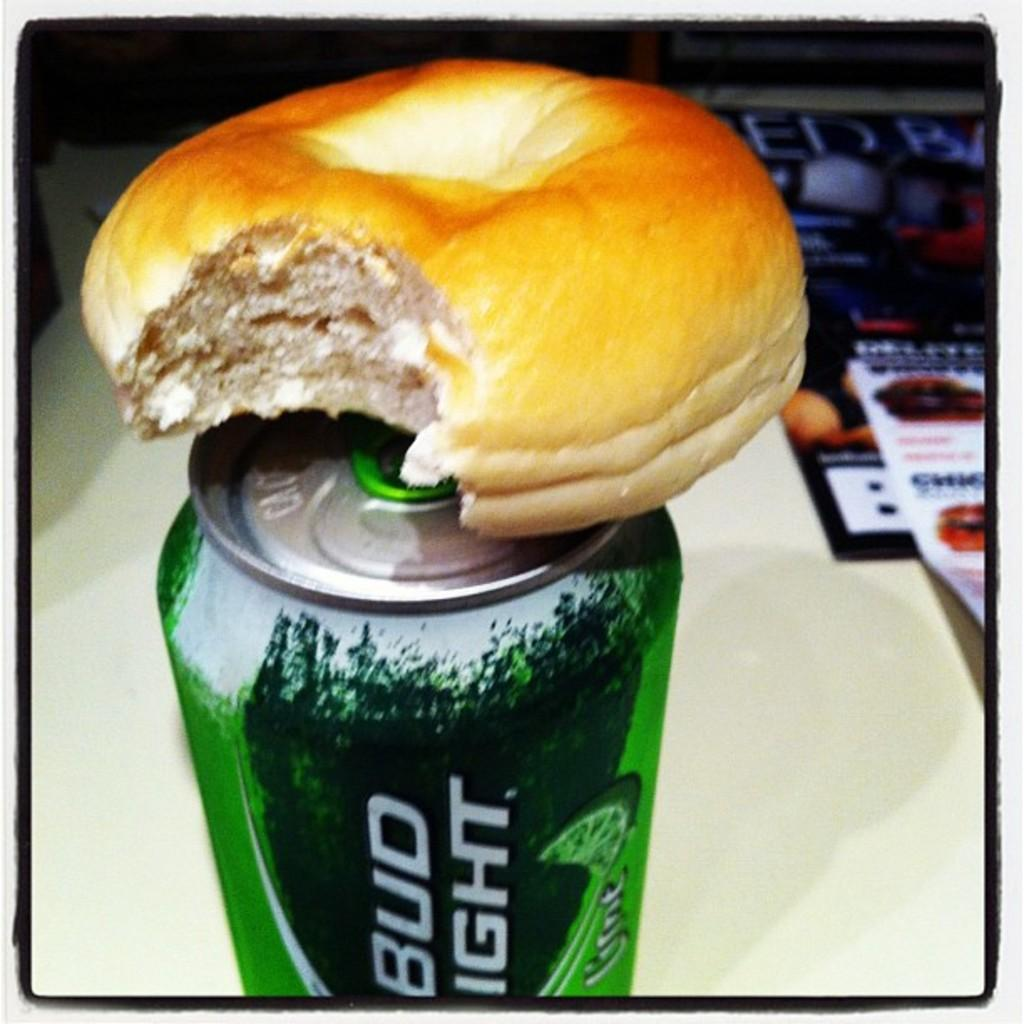What is the main object in the image? There is a tin in the image. What is placed on top of the tin? There is a bun on top of the tin. What can be seen in the background of the image? There is a white surface in the background of the image. What other items are visible in the image? There are magazines in the image. Are there any other objects visible in the image? Yes, there are other objects visible in the image. How does the tin affect the digestion of the bun in the image? The tin does not have any direct impact on the digestion of the bun in the image, as it is an inanimate object. 